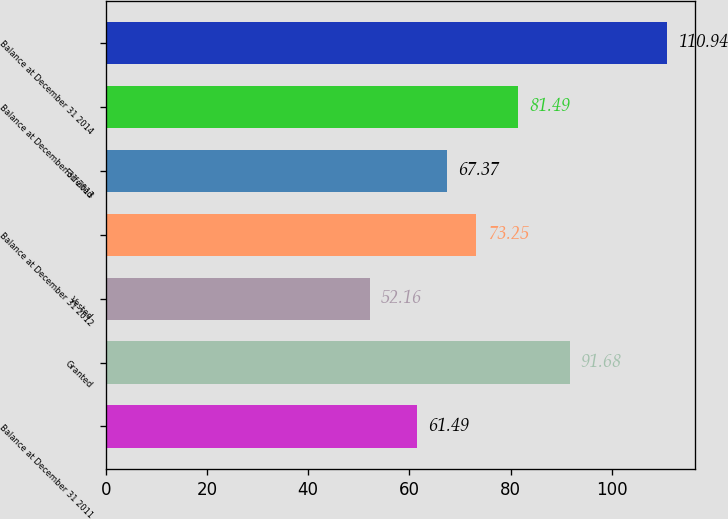Convert chart. <chart><loc_0><loc_0><loc_500><loc_500><bar_chart><fcel>Balance at December 31 2011<fcel>Granted<fcel>Vested<fcel>Balance at December 31 2012<fcel>Forfeited<fcel>Balance at December 31 2013<fcel>Balance at December 31 2014<nl><fcel>61.49<fcel>91.68<fcel>52.16<fcel>73.25<fcel>67.37<fcel>81.49<fcel>110.94<nl></chart> 